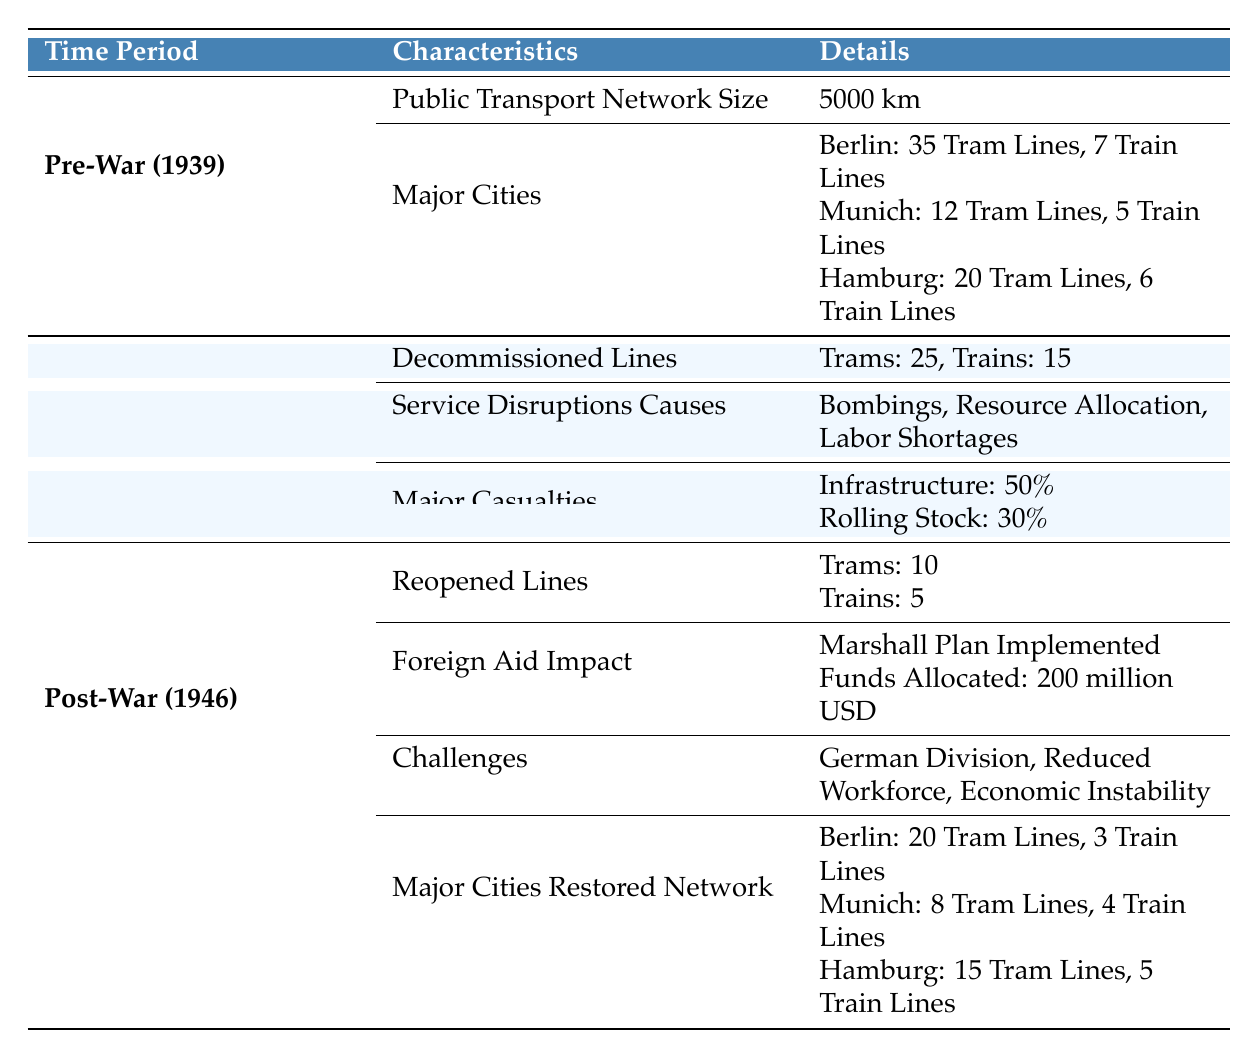What was the public transport network size in Germany in 1939? The table specifies that the public transport network size was 5000 km in 1939 under the Pre-War period.
Answer: 5000 km How many tram lines were in Berlin before the war? According to the table, Berlin had 35 tram lines listed under the Major Cities section for the Pre-War period.
Answer: 35 tram lines What percentage of rolling stock was lost during the war? The table states that there was a 30% loss in rolling stock during the war, noted as a major casualty under the During War period.
Answer: 30% How many total lines were reopened in Munich post-war? The reopened lines in Munich include 8 tram lines and 4 train lines. Therefore, the total is 8 + 4 = 12 reopened lines.
Answer: 12 lines Did the Marshall Plan have an impact on public transport in Germany? The table indicates that the Marshall Plan was implemented and funds amounted to 200 million USD for reconstruction efforts, thus confirming an impact.
Answer: Yes What was the difference in tram lines for Hamburg between the pre-war and post-war periods? Pre-war Hamburg had 20 tram lines, while post-war it had 15 tram lines. The difference is calculated as 20 - 15 = 5 tram lines.
Answer: 5 tram lines What were the main causes for service disruptions during the war? The table lists bombings, resource allocation, and labor shortages as the main causes of service disruptions during the war period.
Answer: Bombings, resource allocation, labor shortages What is the total percentage of infrastructure loss during the war compared to rolling stock loss? The table notes 50% infrastructure loss and 30% rolling stock loss during the war. Adding these values gives 50 + 30 = 80%.
Answer: 80% How many train lines were present in Berlin post-war? The table shows that Berlin had 3 train lines in the major cities restored network section post-war.
Answer: 3 train lines 